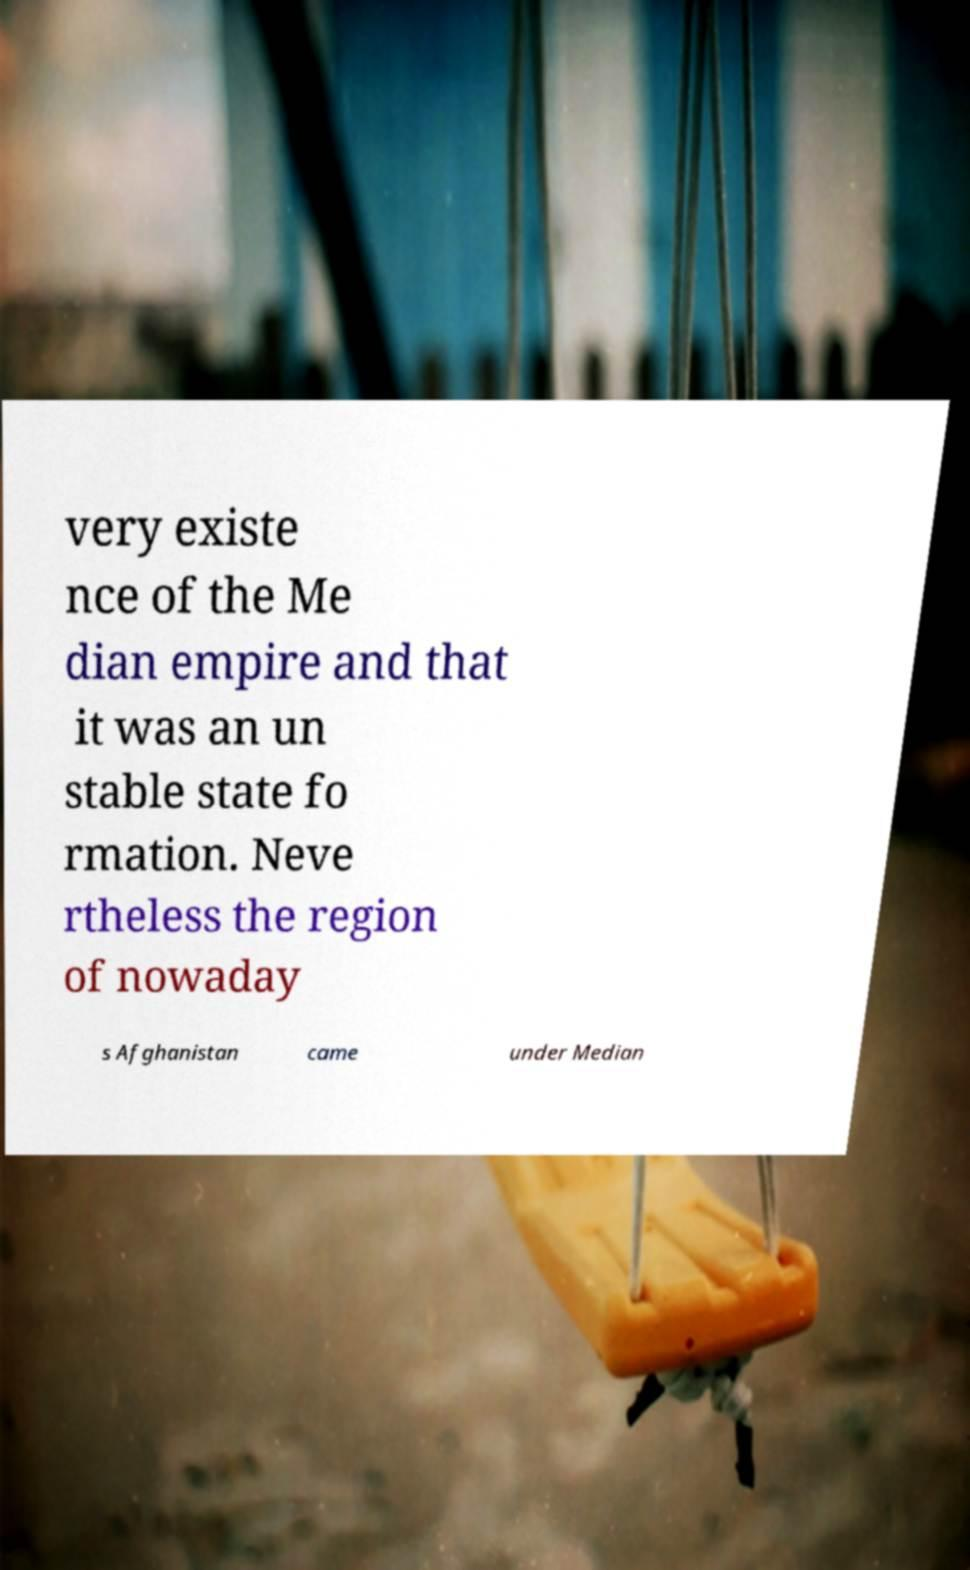What messages or text are displayed in this image? I need them in a readable, typed format. very existe nce of the Me dian empire and that it was an un stable state fo rmation. Neve rtheless the region of nowaday s Afghanistan came under Median 